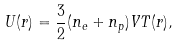Convert formula to latex. <formula><loc_0><loc_0><loc_500><loc_500>U ( r ) = \frac { 3 } { 2 } ( n _ { e } + n _ { p } ) V T ( r ) ,</formula> 